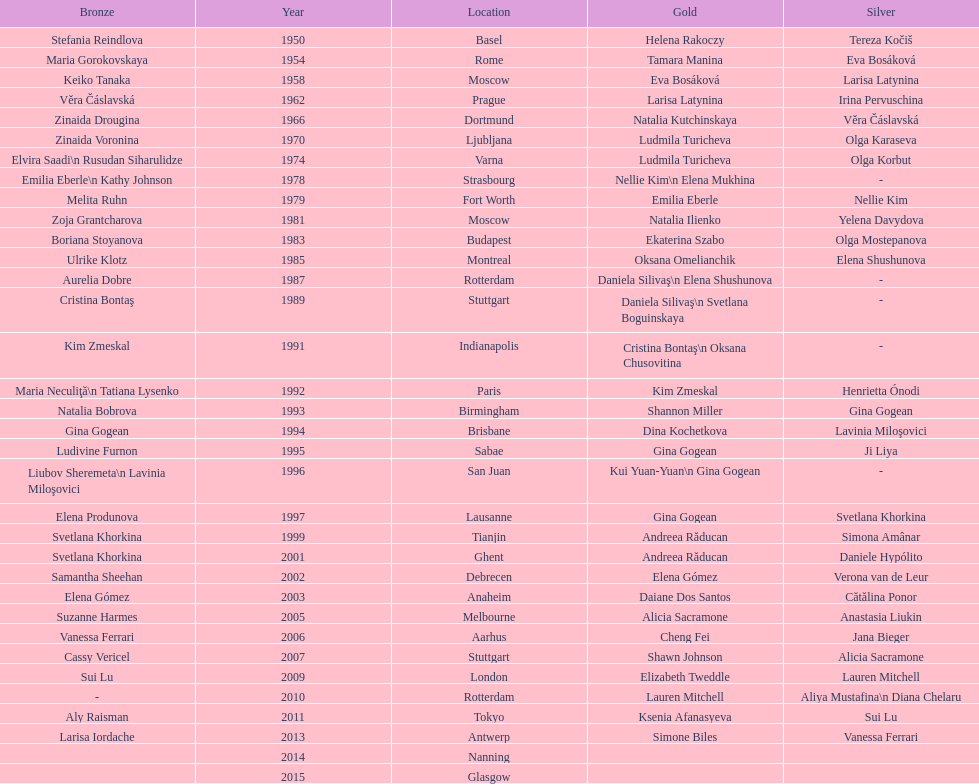Could you help me parse every detail presented in this table? {'header': ['Bronze', 'Year', 'Location', 'Gold', 'Silver'], 'rows': [['Stefania Reindlova', '1950', 'Basel', 'Helena Rakoczy', 'Tereza Kočiš'], ['Maria Gorokovskaya', '1954', 'Rome', 'Tamara Manina', 'Eva Bosáková'], ['Keiko Tanaka', '1958', 'Moscow', 'Eva Bosáková', 'Larisa Latynina'], ['Věra Čáslavská', '1962', 'Prague', 'Larisa Latynina', 'Irina Pervuschina'], ['Zinaida Drougina', '1966', 'Dortmund', 'Natalia Kutchinskaya', 'Věra Čáslavská'], ['Zinaida Voronina', '1970', 'Ljubljana', 'Ludmila Turicheva', 'Olga Karaseva'], ['Elvira Saadi\\n Rusudan Siharulidze', '1974', 'Varna', 'Ludmila Turicheva', 'Olga Korbut'], ['Emilia Eberle\\n Kathy Johnson', '1978', 'Strasbourg', 'Nellie Kim\\n Elena Mukhina', '-'], ['Melita Ruhn', '1979', 'Fort Worth', 'Emilia Eberle', 'Nellie Kim'], ['Zoja Grantcharova', '1981', 'Moscow', 'Natalia Ilienko', 'Yelena Davydova'], ['Boriana Stoyanova', '1983', 'Budapest', 'Ekaterina Szabo', 'Olga Mostepanova'], ['Ulrike Klotz', '1985', 'Montreal', 'Oksana Omelianchik', 'Elena Shushunova'], ['Aurelia Dobre', '1987', 'Rotterdam', 'Daniela Silivaş\\n Elena Shushunova', '-'], ['Cristina Bontaş', '1989', 'Stuttgart', 'Daniela Silivaş\\n Svetlana Boguinskaya', '-'], ['Kim Zmeskal', '1991', 'Indianapolis', 'Cristina Bontaş\\n Oksana Chusovitina', '-'], ['Maria Neculiţă\\n Tatiana Lysenko', '1992', 'Paris', 'Kim Zmeskal', 'Henrietta Ónodi'], ['Natalia Bobrova', '1993', 'Birmingham', 'Shannon Miller', 'Gina Gogean'], ['Gina Gogean', '1994', 'Brisbane', 'Dina Kochetkova', 'Lavinia Miloşovici'], ['Ludivine Furnon', '1995', 'Sabae', 'Gina Gogean', 'Ji Liya'], ['Liubov Sheremeta\\n Lavinia Miloşovici', '1996', 'San Juan', 'Kui Yuan-Yuan\\n Gina Gogean', '-'], ['Elena Produnova', '1997', 'Lausanne', 'Gina Gogean', 'Svetlana Khorkina'], ['Svetlana Khorkina', '1999', 'Tianjin', 'Andreea Răducan', 'Simona Amânar'], ['Svetlana Khorkina', '2001', 'Ghent', 'Andreea Răducan', 'Daniele Hypólito'], ['Samantha Sheehan', '2002', 'Debrecen', 'Elena Gómez', 'Verona van de Leur'], ['Elena Gómez', '2003', 'Anaheim', 'Daiane Dos Santos', 'Cătălina Ponor'], ['Suzanne Harmes', '2005', 'Melbourne', 'Alicia Sacramone', 'Anastasia Liukin'], ['Vanessa Ferrari', '2006', 'Aarhus', 'Cheng Fei', 'Jana Bieger'], ['Cassy Vericel', '2007', 'Stuttgart', 'Shawn Johnson', 'Alicia Sacramone'], ['Sui Lu', '2009', 'London', 'Elizabeth Tweddle', 'Lauren Mitchell'], ['-', '2010', 'Rotterdam', 'Lauren Mitchell', 'Aliya Mustafina\\n Diana Chelaru'], ['Aly Raisman', '2011', 'Tokyo', 'Ksenia Afanasyeva', 'Sui Lu'], ['Larisa Iordache', '2013', 'Antwerp', 'Simone Biles', 'Vanessa Ferrari'], ['', '2014', 'Nanning', '', ''], ['', '2015', 'Glasgow', '', '']]} As of 2013, what is the total number of floor exercise gold medals won by american women at the world championships? 5. 